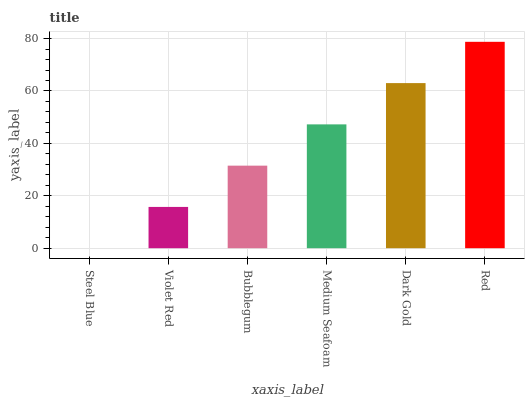Is Steel Blue the minimum?
Answer yes or no. Yes. Is Red the maximum?
Answer yes or no. Yes. Is Violet Red the minimum?
Answer yes or no. No. Is Violet Red the maximum?
Answer yes or no. No. Is Violet Red greater than Steel Blue?
Answer yes or no. Yes. Is Steel Blue less than Violet Red?
Answer yes or no. Yes. Is Steel Blue greater than Violet Red?
Answer yes or no. No. Is Violet Red less than Steel Blue?
Answer yes or no. No. Is Medium Seafoam the high median?
Answer yes or no. Yes. Is Bubblegum the low median?
Answer yes or no. Yes. Is Red the high median?
Answer yes or no. No. Is Violet Red the low median?
Answer yes or no. No. 